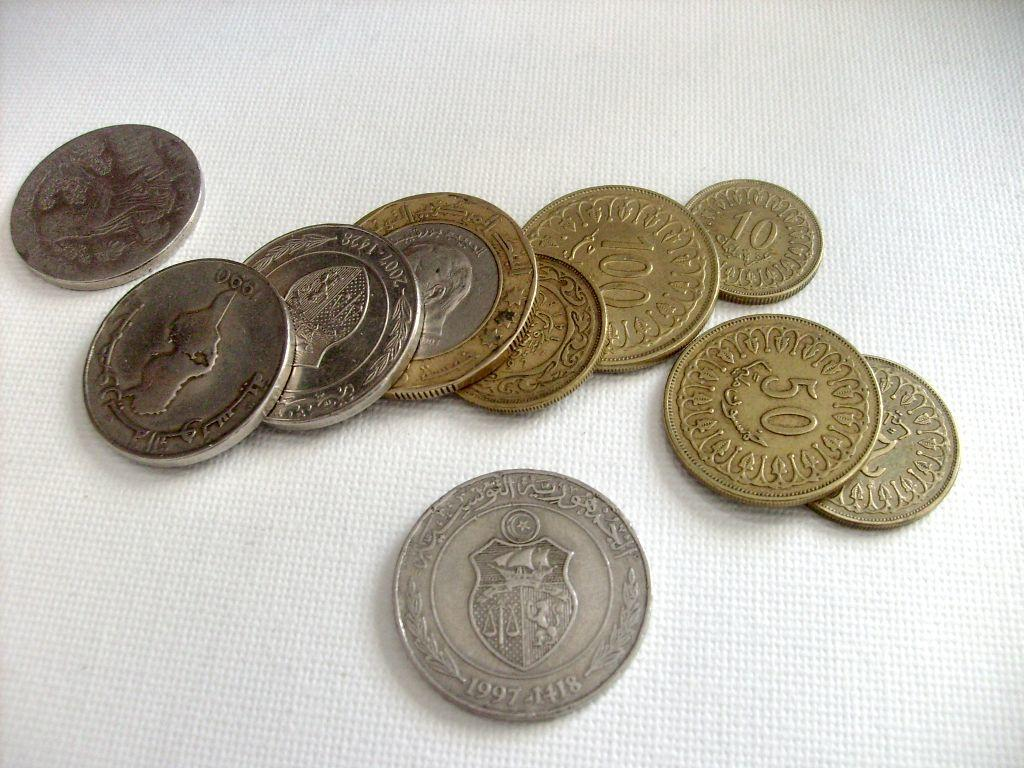<image>
Create a compact narrative representing the image presented. a coin with others that have 50 and 100 on them 